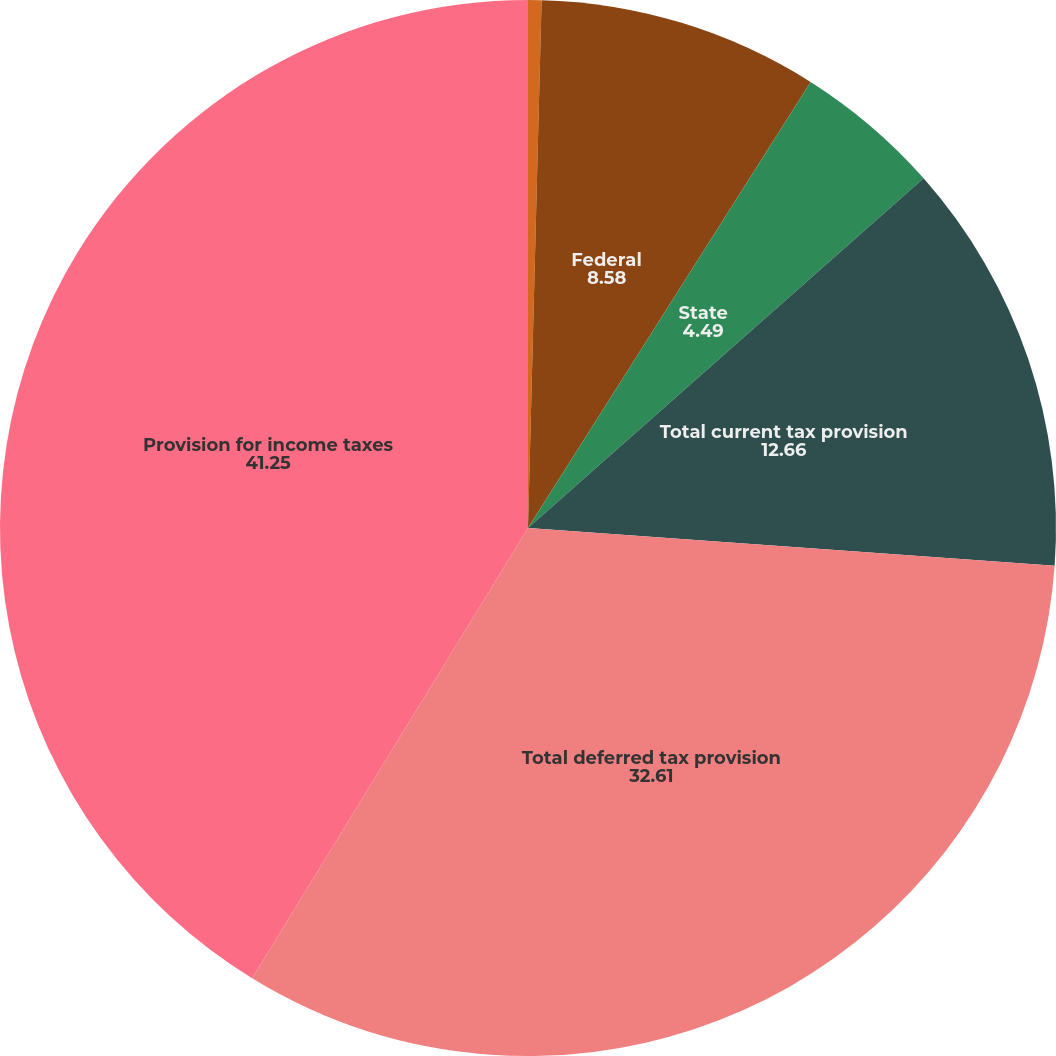Convert chart to OTSL. <chart><loc_0><loc_0><loc_500><loc_500><pie_chart><fcel>(dollar amounts in thousands)<fcel>Federal<fcel>State<fcel>Total current tax provision<fcel>Total deferred tax provision<fcel>Provision for income taxes<nl><fcel>0.41%<fcel>8.58%<fcel>4.49%<fcel>12.66%<fcel>32.61%<fcel>41.25%<nl></chart> 